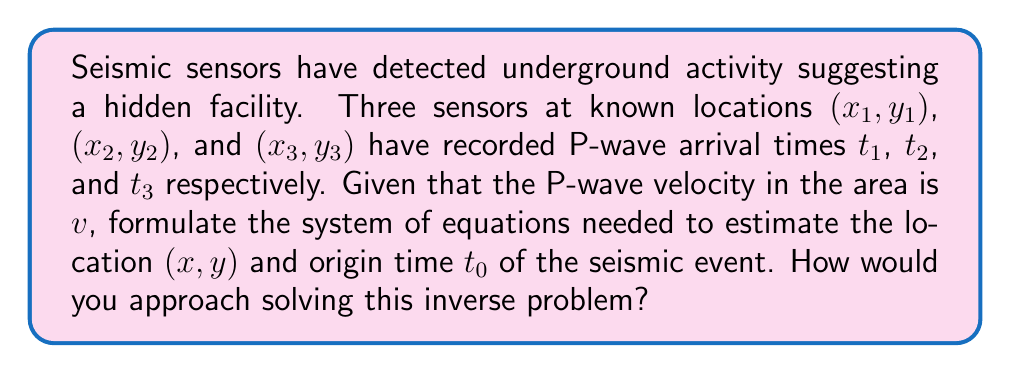Can you answer this question? To estimate the location of the hidden facility based on seismic readings, we need to set up and solve an inverse problem. Here's the step-by-step approach:

1) First, we formulate the forward problem. The travel time $t_i$ for a P-wave from the source $(x, y)$ to a sensor $(x_i, y_i)$ is given by:

   $$t_i - t_0 = \frac{\sqrt{(x - x_i)^2 + (y - y_i)^2}}{v}$$

   where $t_0$ is the origin time of the event and $v$ is the P-wave velocity.

2) We have three equations (one for each sensor) and three unknowns $(x, y, t_0)$:

   $$t_1 - t_0 = \frac{\sqrt{(x - x_1)^2 + (y - y_1)^2}}{v}$$
   $$t_2 - t_0 = \frac{\sqrt{(x - x_2)^2 + (y - y_2)^2}}{v}$$
   $$t_3 - t_0 = \frac{\sqrt{(x - x_3)^2 + (y - y_3)^2}}{v}$$

3) This system is nonlinear and cannot be solved analytically. To solve this inverse problem, we would typically use an iterative method such as:

   a) Linearization and least squares: Linearize the equations around an initial guess and solve using least squares. Iterate until convergence.
   
   b) Grid search: Create a grid of possible $(x, y, t_0)$ values and find the combination that minimizes the misfit between observed and calculated travel times.
   
   c) Nonlinear optimization: Use methods like Levenberg-Marquardt or Nelder-Mead to minimize the misfit function.

4) The misfit function to minimize would typically be:

   $$F(x, y, t_0) = \sum_{i=1}^3 \left(t_i - t_0 - \frac{\sqrt{(x - x_i)^2 + (y - y_i)^2}}{v}\right)^2$$

5) Once the optimal $(x, y, t_0)$ is found, we have estimated the location of the seismic event and its origin time, which likely corresponds to the location of the hidden underground facility.

6) To assess uncertainty, we would perform error analysis, possibly using Monte Carlo methods or calculating the covariance matrix of the solution.
Answer: Formulate nonlinear system: $t_i - t_0 = \frac{\sqrt{(x - x_i)^2 + (y - y_i)^2}}{v}$ for $i=1,2,3$. Solve using iterative methods (e.g., linearization, grid search, or nonlinear optimization). 